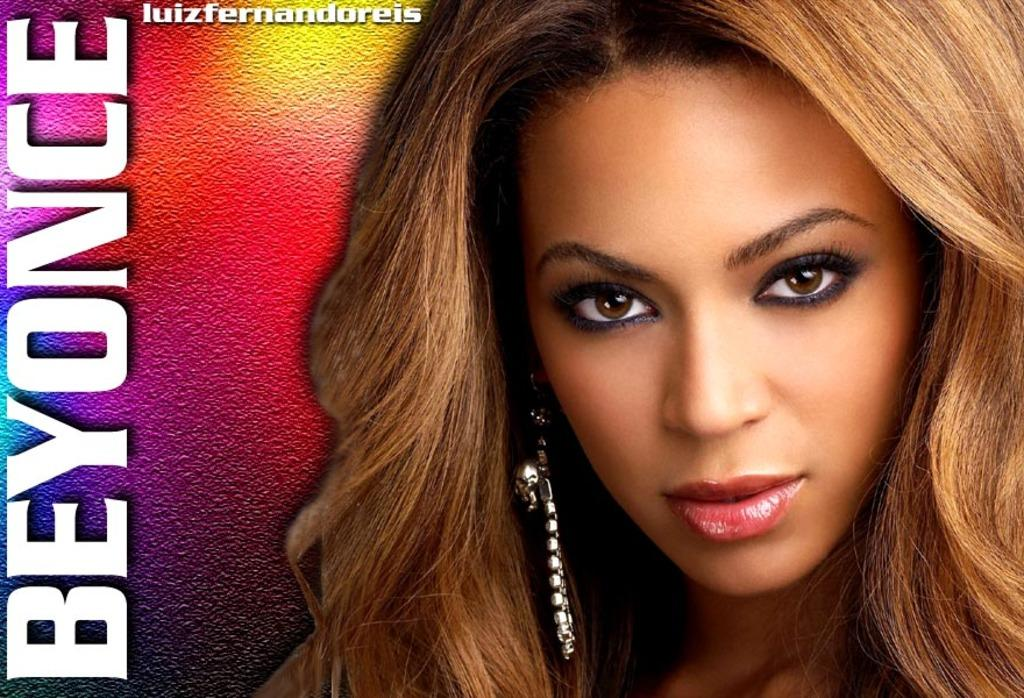What is the main subject of the image? The main subject of the image is a photo of a singer. Is there any text accompanying the photo? Yes, the singer's name is printed beside the photo. How many balls are visible in the image? There are no balls present in the image. Is there a goat in the image? No, there is no goat in the image. 